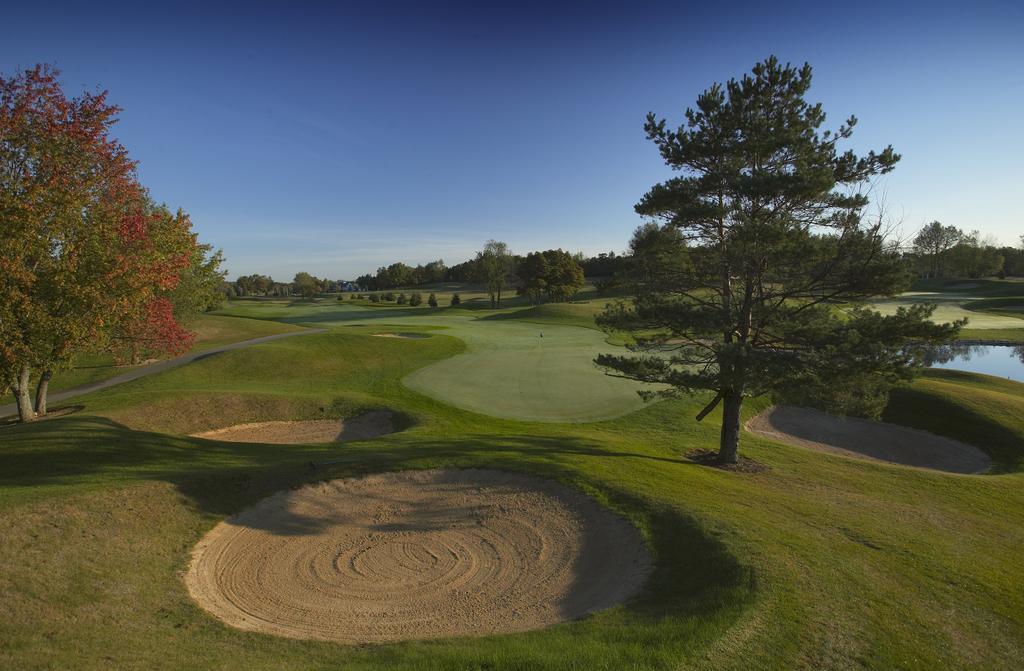What type of vegetation can be seen in the image? There are trees in the image. What is on the ground in the image? There is grass on the ground in the image. What natural element is visible in the image? There is water visible in the image. What color is the sky in the image? The sky is blue in the image. Where are the scissors located in the image? There are no scissors present in the image. What type of fowl can be seen in the image? There are no fowl present in the image. 